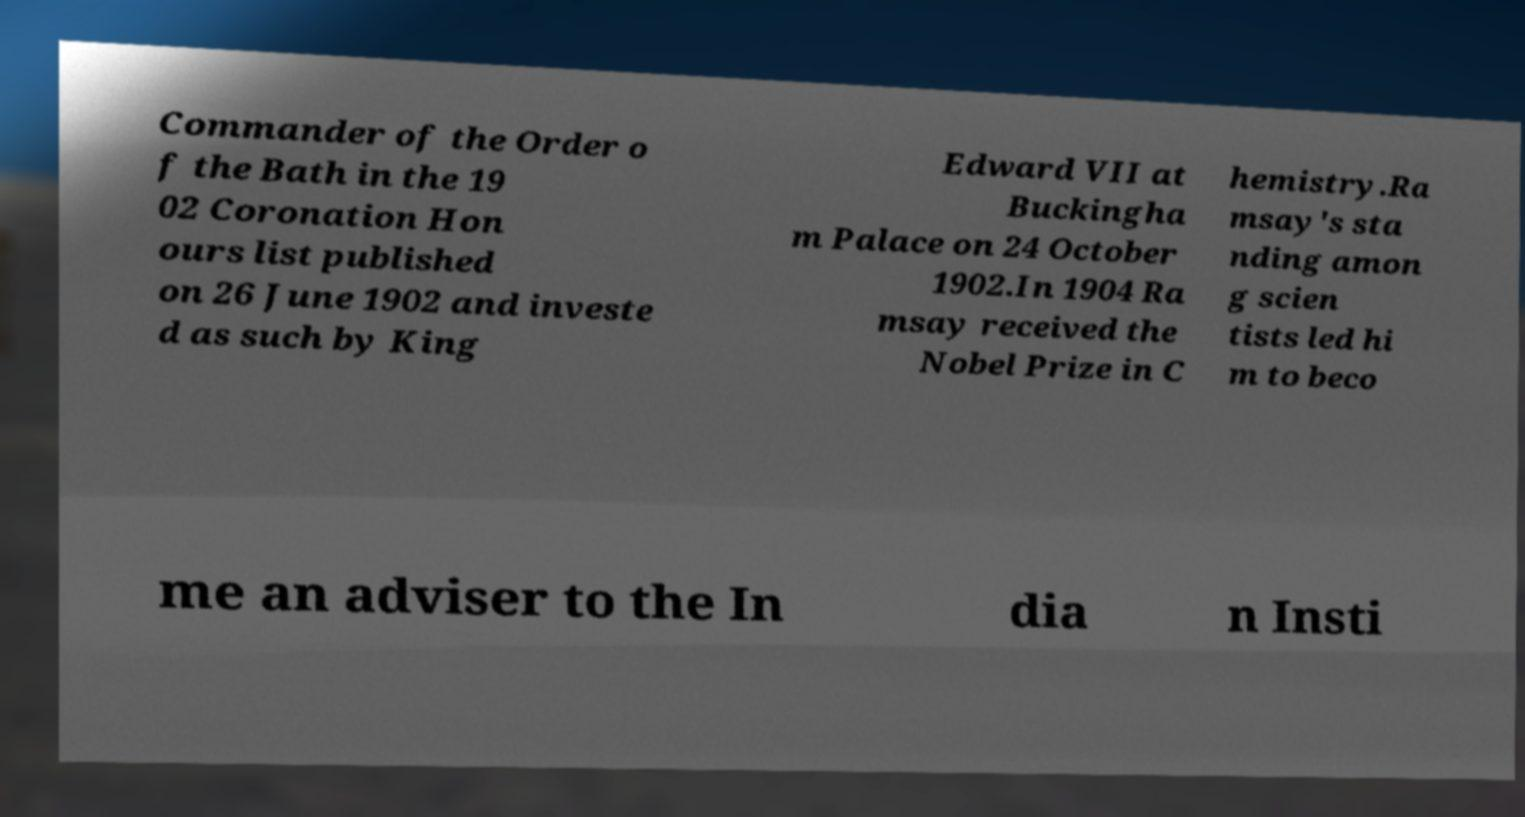Please read and relay the text visible in this image. What does it say? Commander of the Order o f the Bath in the 19 02 Coronation Hon ours list published on 26 June 1902 and investe d as such by King Edward VII at Buckingha m Palace on 24 October 1902.In 1904 Ra msay received the Nobel Prize in C hemistry.Ra msay's sta nding amon g scien tists led hi m to beco me an adviser to the In dia n Insti 